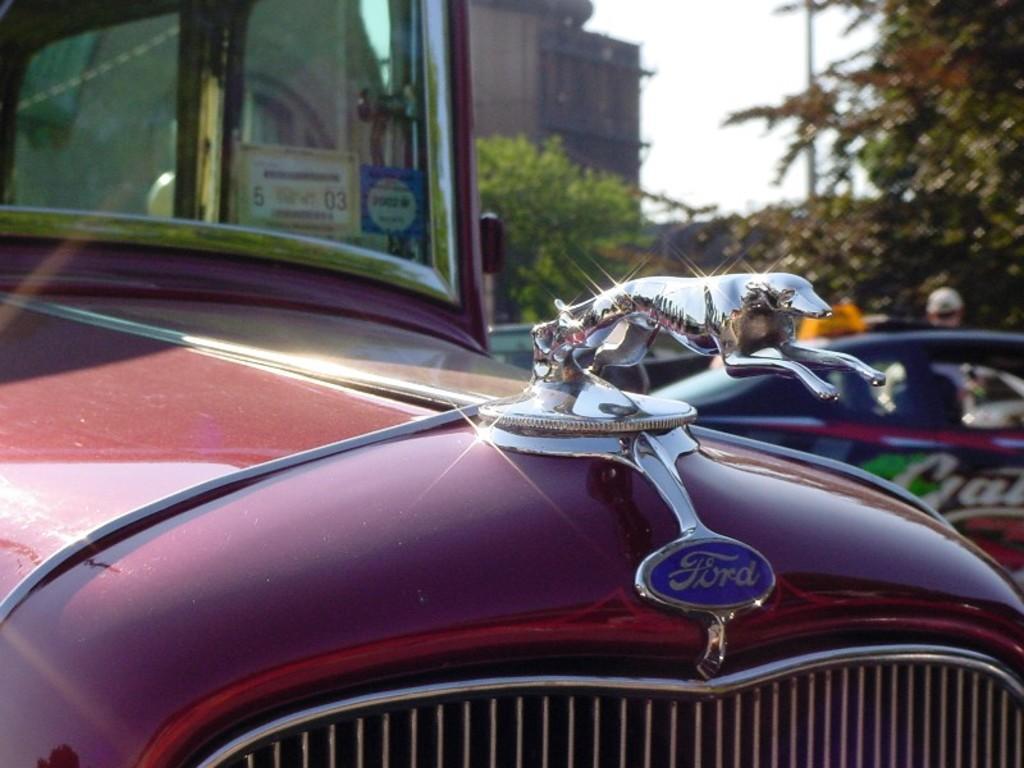Please provide a concise description of this image. This is the front view of a vehicle. In this image we can see a glass window, logo, bumper and other objects. In the background of the image there are vehicles, trees, building, sky and other objects. 